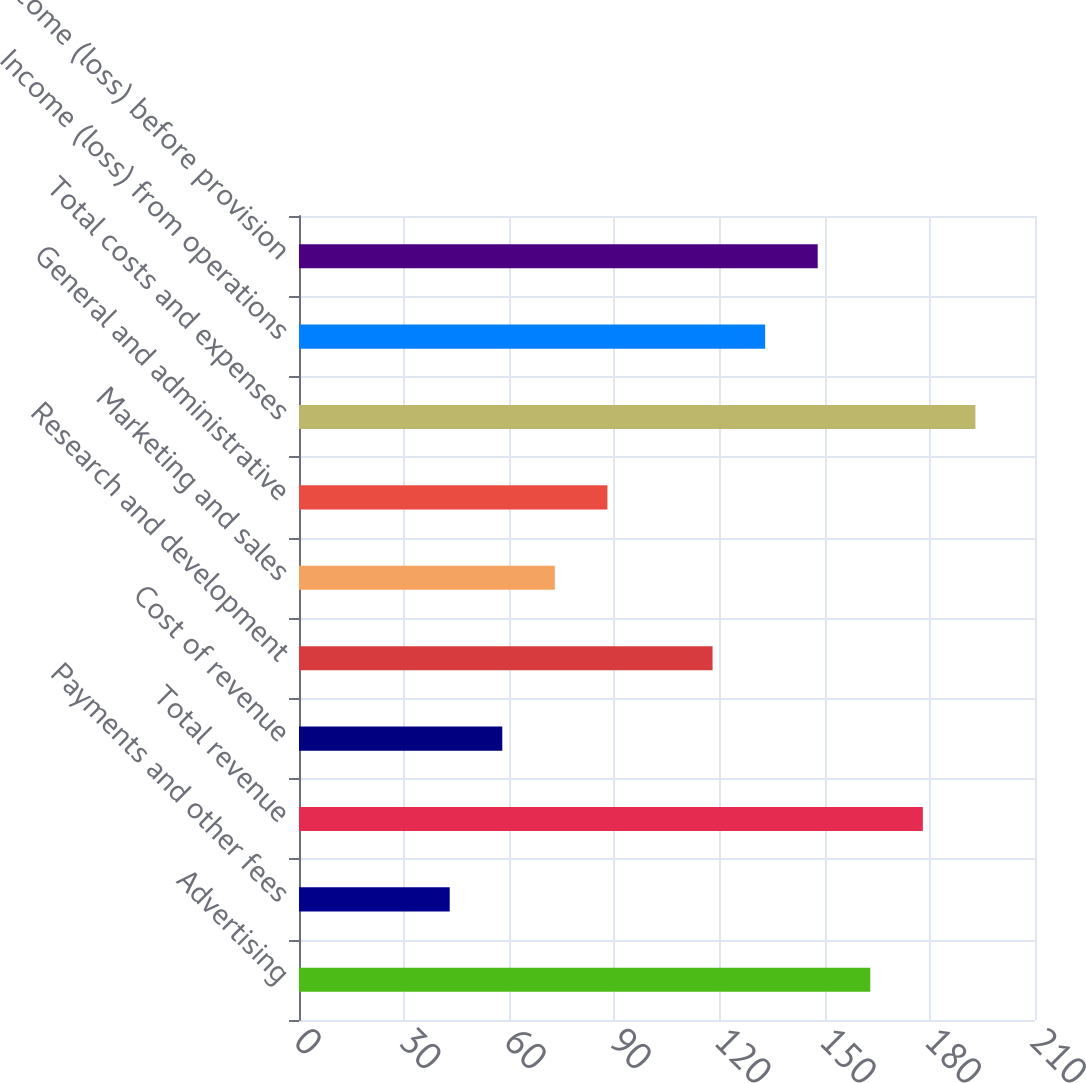Convert chart. <chart><loc_0><loc_0><loc_500><loc_500><bar_chart><fcel>Advertising<fcel>Payments and other fees<fcel>Total revenue<fcel>Cost of revenue<fcel>Research and development<fcel>Marketing and sales<fcel>General and administrative<fcel>Total costs and expenses<fcel>Income (loss) from operations<fcel>Income (loss) before provision<nl><fcel>163<fcel>43<fcel>178<fcel>58<fcel>118<fcel>73<fcel>88<fcel>193<fcel>133<fcel>148<nl></chart> 